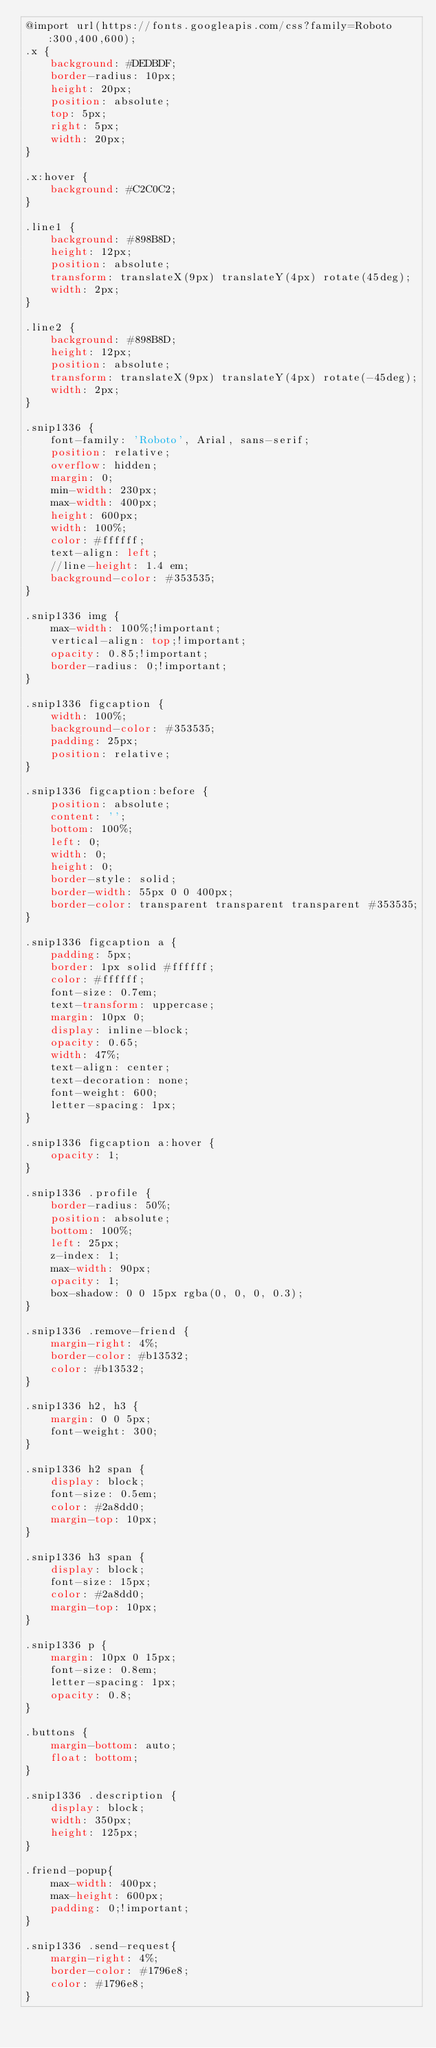<code> <loc_0><loc_0><loc_500><loc_500><_CSS_>@import url(https://fonts.googleapis.com/css?family=Roboto:300,400,600);
.x {
    background: #DEDBDF;
    border-radius: 10px;
    height: 20px;
    position: absolute;
    top: 5px;
    right: 5px;
    width: 20px;
}

.x:hover {
    background: #C2C0C2;
}

.line1 {
    background: #898B8D;
    height: 12px;
    position: absolute;
    transform: translateX(9px) translateY(4px) rotate(45deg);
    width: 2px;
}

.line2 {
    background: #898B8D;
    height: 12px;
    position: absolute;
    transform: translateX(9px) translateY(4px) rotate(-45deg);
    width: 2px;
}

.snip1336 {
    font-family: 'Roboto', Arial, sans-serif;
    position: relative;
    overflow: hidden;
    margin: 0;
    min-width: 230px;
    max-width: 400px;
    height: 600px;
    width: 100%;
    color: #ffffff;
    text-align: left;
    //line-height: 1.4 em;
    background-color: #353535;
}

.snip1336 img {
    max-width: 100%;!important;
    vertical-align: top;!important;
    opacity: 0.85;!important;
    border-radius: 0;!important;
}

.snip1336 figcaption {
    width: 100%;
    background-color: #353535;
    padding: 25px;
    position: relative;
}

.snip1336 figcaption:before {
    position: absolute;
    content: '';
    bottom: 100%;
    left: 0;
    width: 0;
    height: 0;
    border-style: solid;
    border-width: 55px 0 0 400px;
    border-color: transparent transparent transparent #353535;
}

.snip1336 figcaption a {
    padding: 5px;
    border: 1px solid #ffffff;
    color: #ffffff;
    font-size: 0.7em;
    text-transform: uppercase;
    margin: 10px 0;
    display: inline-block;
    opacity: 0.65;
    width: 47%;
    text-align: center;
    text-decoration: none;
    font-weight: 600;
    letter-spacing: 1px;
}

.snip1336 figcaption a:hover {
    opacity: 1;
}

.snip1336 .profile {
    border-radius: 50%;
    position: absolute;
    bottom: 100%;
    left: 25px;
    z-index: 1;
    max-width: 90px;
    opacity: 1;
    box-shadow: 0 0 15px rgba(0, 0, 0, 0.3);
}

.snip1336 .remove-friend {
    margin-right: 4%;
    border-color: #b13532;
    color: #b13532;
}

.snip1336 h2, h3 {
    margin: 0 0 5px;
    font-weight: 300;
}

.snip1336 h2 span {
    display: block;
    font-size: 0.5em;
    color: #2a8dd0;
    margin-top: 10px;
}

.snip1336 h3 span {
    display: block;
    font-size: 15px;
    color: #2a8dd0;
    margin-top: 10px;
}

.snip1336 p {
    margin: 10px 0 15px;
    font-size: 0.8em;
    letter-spacing: 1px;
    opacity: 0.8;
}

.buttons {
    margin-bottom: auto;
    float: bottom;
}

.snip1336 .description {
    display: block;
    width: 350px;
    height: 125px;
}

.friend-popup{
    max-width: 400px;
    max-height: 600px;
    padding: 0;!important;
}

.snip1336 .send-request{
    margin-right: 4%;
    border-color: #1796e8;
    color: #1796e8;
}</code> 